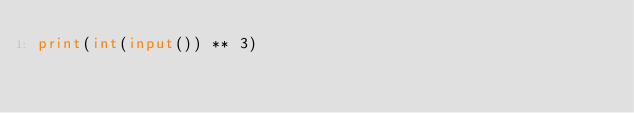<code> <loc_0><loc_0><loc_500><loc_500><_Python_>print(int(input()) ** 3)</code> 